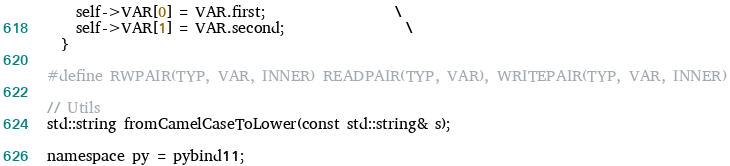Convert code to text. <code><loc_0><loc_0><loc_500><loc_500><_C_>    self->VAR[0] = VAR.first;                  \
    self->VAR[1] = VAR.second;                 \
  }

#define RWPAIR(TYP, VAR, INNER) READPAIR(TYP, VAR), WRITEPAIR(TYP, VAR, INNER)

// Utils
std::string fromCamelCaseToLower(const std::string& s);

namespace py = pybind11;
</code> 